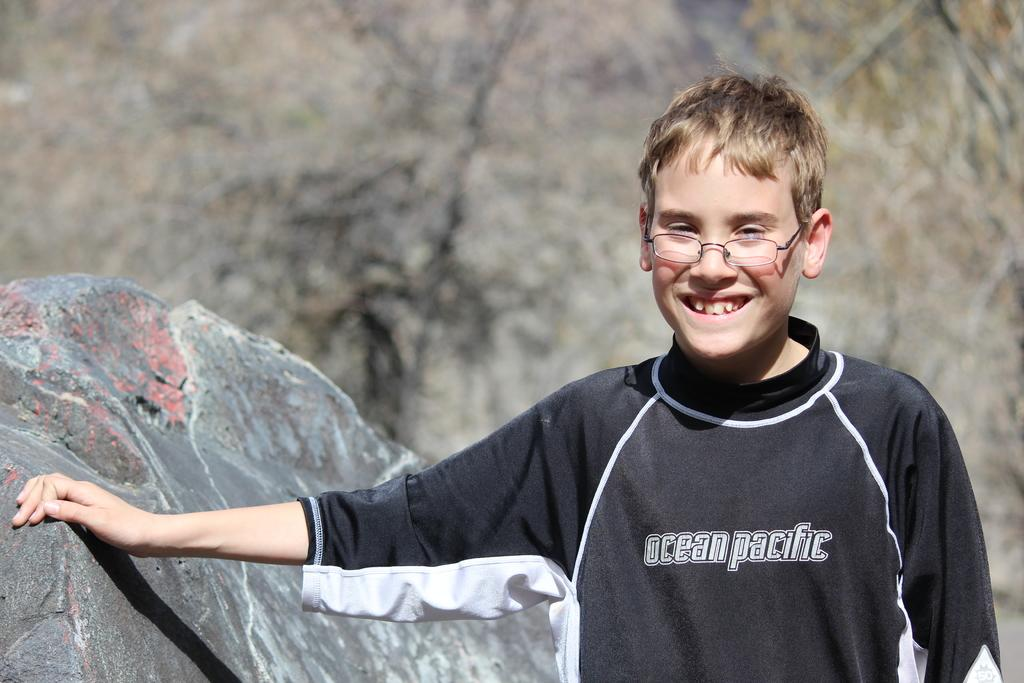<image>
Share a concise interpretation of the image provided. A young boy stands outside wearing glasses and a dark Ocean Pacific shirt. 